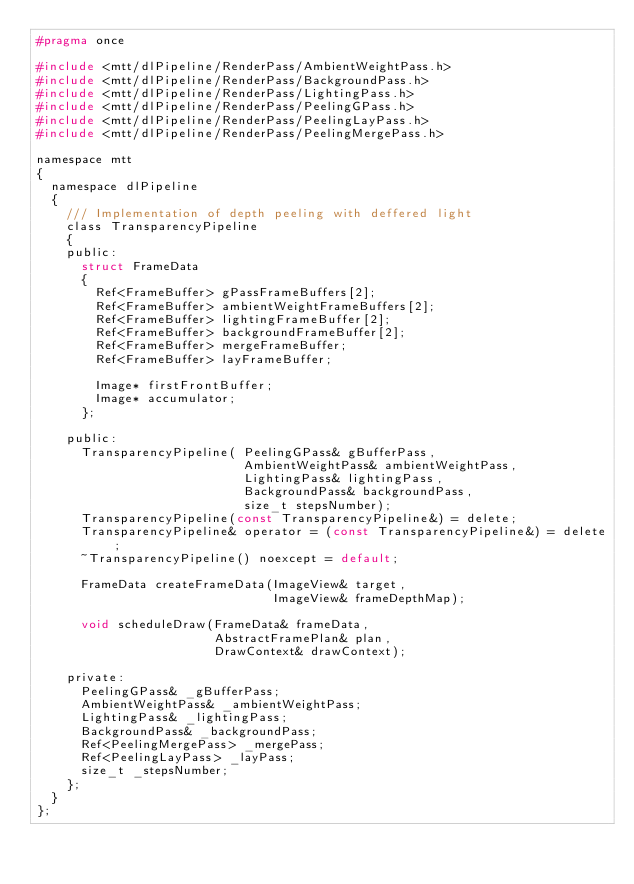Convert code to text. <code><loc_0><loc_0><loc_500><loc_500><_C_>#pragma once

#include <mtt/dlPipeline/RenderPass/AmbientWeightPass.h>
#include <mtt/dlPipeline/RenderPass/BackgroundPass.h>
#include <mtt/dlPipeline/RenderPass/LightingPass.h>
#include <mtt/dlPipeline/RenderPass/PeelingGPass.h>
#include <mtt/dlPipeline/RenderPass/PeelingLayPass.h>
#include <mtt/dlPipeline/RenderPass/PeelingMergePass.h>

namespace mtt
{
  namespace dlPipeline
  {
    /// Implementation of depth peeling with deffered light
    class TransparencyPipeline
    {
    public:
      struct FrameData
      {
        Ref<FrameBuffer> gPassFrameBuffers[2];
        Ref<FrameBuffer> ambientWeightFrameBuffers[2];
        Ref<FrameBuffer> lightingFrameBuffer[2];
        Ref<FrameBuffer> backgroundFrameBuffer[2];
        Ref<FrameBuffer> mergeFrameBuffer;
        Ref<FrameBuffer> layFrameBuffer;

        Image* firstFrontBuffer;
        Image* accumulator;
      };

    public:
      TransparencyPipeline( PeelingGPass& gBufferPass,
                            AmbientWeightPass& ambientWeightPass,
                            LightingPass& lightingPass,
                            BackgroundPass& backgroundPass,
                            size_t stepsNumber);
      TransparencyPipeline(const TransparencyPipeline&) = delete;
      TransparencyPipeline& operator = (const TransparencyPipeline&) = delete;
      ~TransparencyPipeline() noexcept = default;
  
      FrameData createFrameData(ImageView& target,
                                ImageView& frameDepthMap);

      void scheduleDraw(FrameData& frameData,
                        AbstractFramePlan& plan,
                        DrawContext& drawContext);

    private:
      PeelingGPass& _gBufferPass;
      AmbientWeightPass& _ambientWeightPass;
      LightingPass& _lightingPass;
      BackgroundPass& _backgroundPass;
      Ref<PeelingMergePass> _mergePass;
      Ref<PeelingLayPass> _layPass;
      size_t _stepsNumber;
    };
  }
};
</code> 